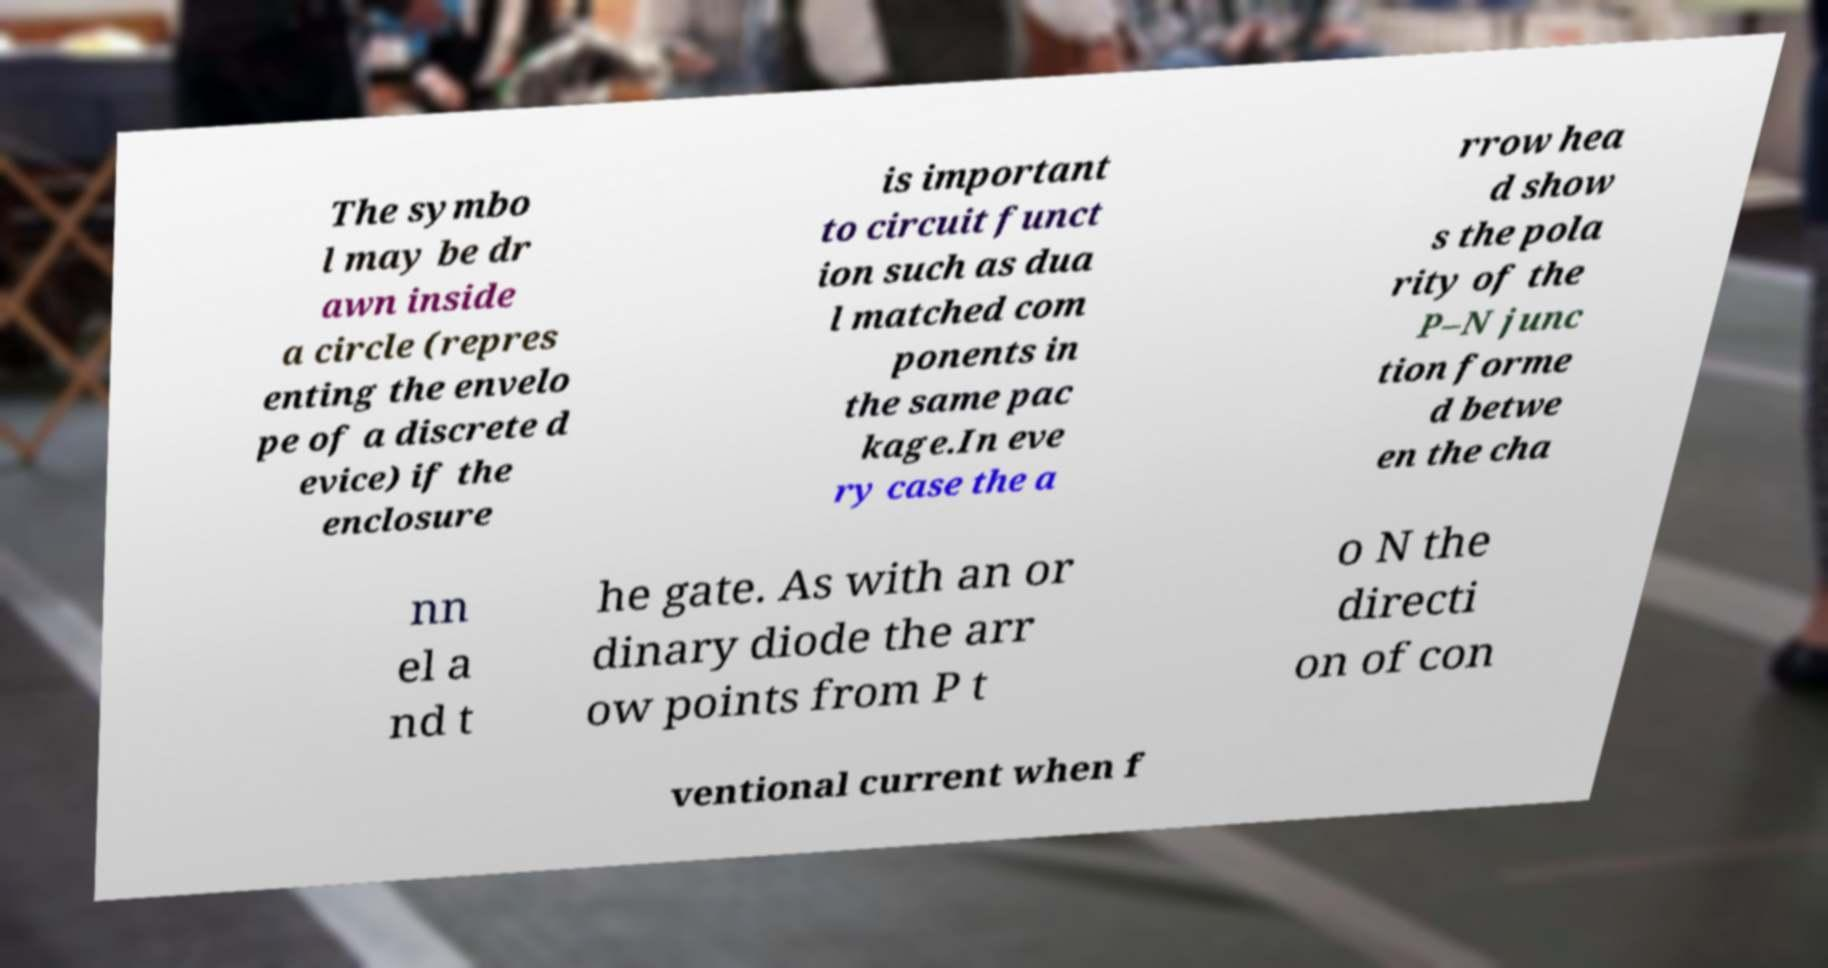Please identify and transcribe the text found in this image. The symbo l may be dr awn inside a circle (repres enting the envelo pe of a discrete d evice) if the enclosure is important to circuit funct ion such as dua l matched com ponents in the same pac kage.In eve ry case the a rrow hea d show s the pola rity of the P–N junc tion forme d betwe en the cha nn el a nd t he gate. As with an or dinary diode the arr ow points from P t o N the directi on of con ventional current when f 